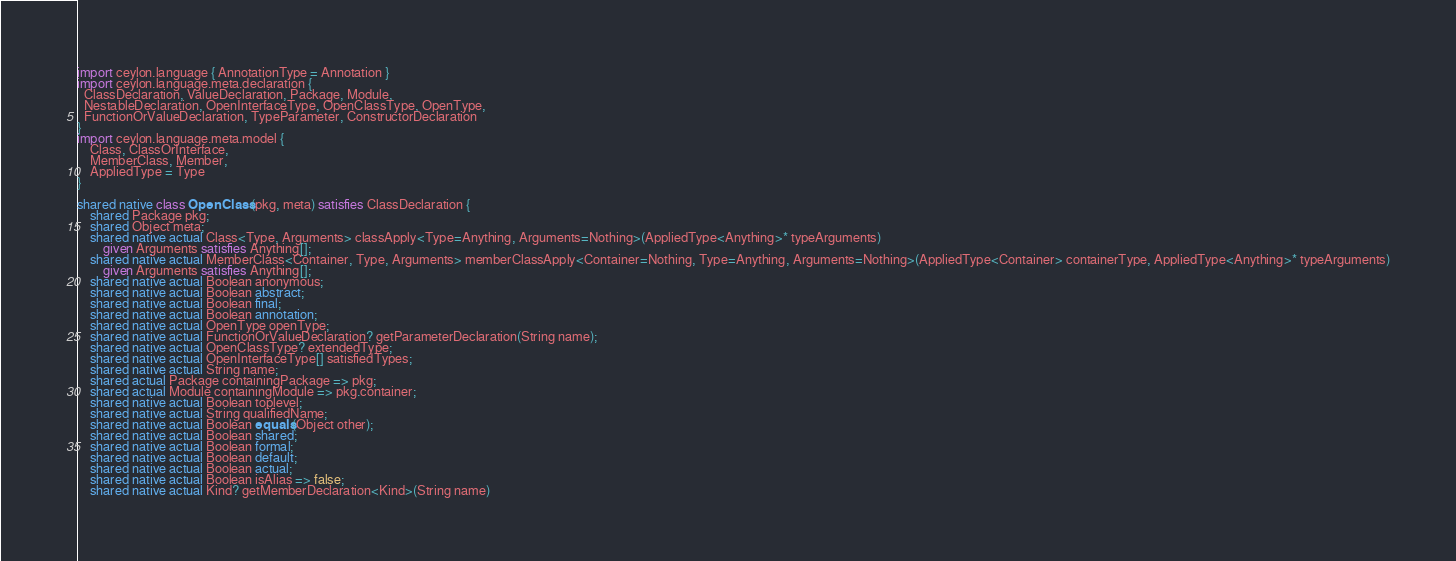<code> <loc_0><loc_0><loc_500><loc_500><_Ceylon_>import ceylon.language { AnnotationType = Annotation }
import ceylon.language.meta.declaration {
  ClassDeclaration, ValueDeclaration, Package, Module,
  NestableDeclaration, OpenInterfaceType, OpenClassType, OpenType,
  FunctionOrValueDeclaration, TypeParameter, ConstructorDeclaration
}
import ceylon.language.meta.model {
    Class, ClassOrInterface,
    MemberClass, Member,
    AppliedType = Type
}

shared native class OpenClass(pkg, meta) satisfies ClassDeclaration {
    shared Package pkg;
    shared Object meta;
    shared native actual Class<Type, Arguments> classApply<Type=Anything, Arguments=Nothing>(AppliedType<Anything>* typeArguments)
        given Arguments satisfies Anything[];
    shared native actual MemberClass<Container, Type, Arguments> memberClassApply<Container=Nothing, Type=Anything, Arguments=Nothing>(AppliedType<Container> containerType, AppliedType<Anything>* typeArguments)
        given Arguments satisfies Anything[];
    shared native actual Boolean anonymous;
    shared native actual Boolean abstract;
    shared native actual Boolean final;
    shared native actual Boolean annotation;
    shared native actual OpenType openType;
    shared native actual FunctionOrValueDeclaration? getParameterDeclaration(String name);
    shared native actual OpenClassType? extendedType;
    shared native actual OpenInterfaceType[] satisfiedTypes;
    shared native actual String name;
    shared actual Package containingPackage => pkg;
    shared actual Module containingModule => pkg.container;
    shared native actual Boolean toplevel;
    shared native actual String qualifiedName;
    shared native actual Boolean equals(Object other);
    shared native actual Boolean shared;
    shared native actual Boolean formal;
    shared native actual Boolean default;
    shared native actual Boolean actual;
    shared native actual Boolean isAlias => false;
    shared native actual Kind? getMemberDeclaration<Kind>(String name) </code> 